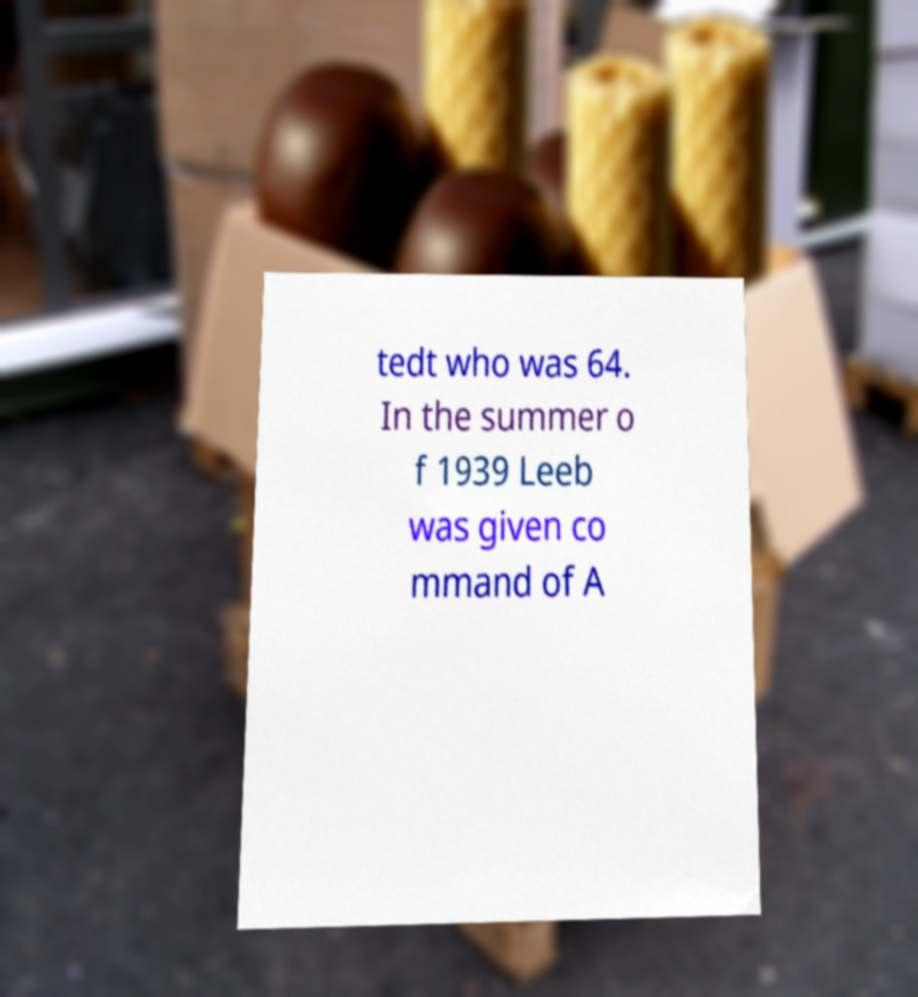Please read and relay the text visible in this image. What does it say? tedt who was 64. In the summer o f 1939 Leeb was given co mmand of A 